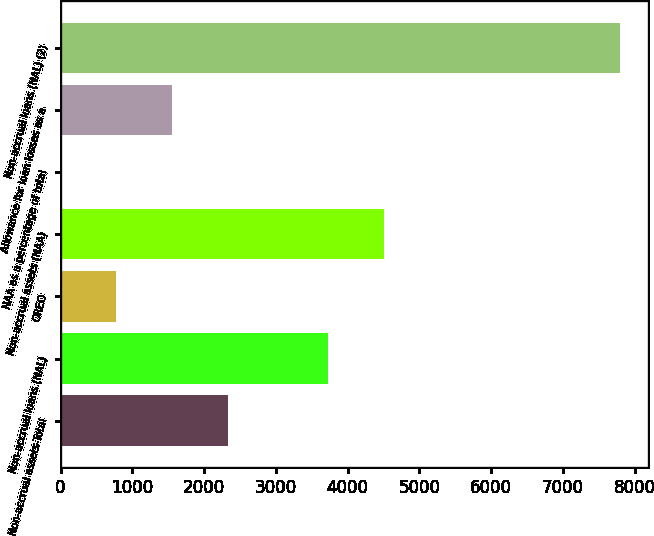Convert chart. <chart><loc_0><loc_0><loc_500><loc_500><bar_chart><fcel>Non-accrual assets-Total<fcel>Non-accrual loans (NAL)<fcel>OREO<fcel>Non-accrual assets (NAA)<fcel>NAA as a percentage of total<fcel>Allowance for loan losses as a<fcel>Non-accrual loans (NAL) (2)<nl><fcel>2338.97<fcel>3734<fcel>779.81<fcel>4513.58<fcel>0.23<fcel>1559.39<fcel>7796<nl></chart> 